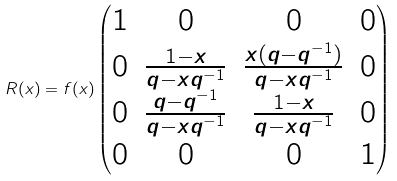<formula> <loc_0><loc_0><loc_500><loc_500>R ( x ) = f ( x ) \begin{pmatrix} 1 & 0 & 0 & 0 \\ 0 & \frac { 1 - x } { q - x q ^ { - 1 } } & \frac { x ( q - q ^ { - 1 } ) } { q - x q ^ { - 1 } } & 0 \\ 0 & \frac { q - q ^ { - 1 } } { q - x q ^ { - 1 } } & \frac { 1 - x } { q - x q ^ { - 1 } } & 0 \\ 0 & 0 & 0 & 1 \end{pmatrix}</formula> 